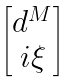<formula> <loc_0><loc_0><loc_500><loc_500>\begin{bmatrix} d ^ { M } \\ i \xi \end{bmatrix}</formula> 